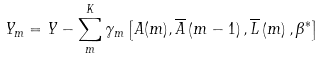Convert formula to latex. <formula><loc_0><loc_0><loc_500><loc_500>Y _ { m } = Y - \sum _ { m } ^ { K } \gamma _ { m } \left [ A ( m ) , \overline { A } \left ( m - 1 \right ) , \overline { L } \left ( m \right ) , \beta ^ { \ast } \right ]</formula> 